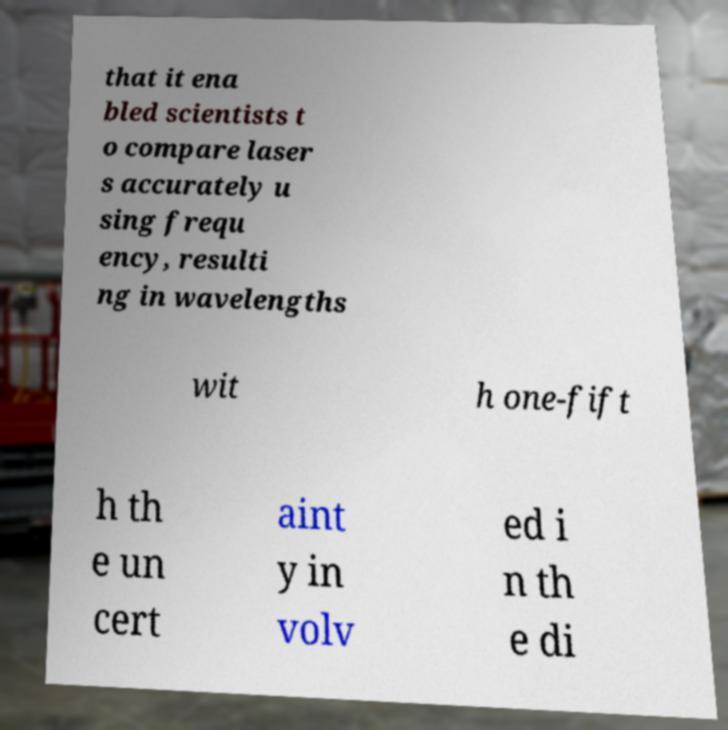There's text embedded in this image that I need extracted. Can you transcribe it verbatim? that it ena bled scientists t o compare laser s accurately u sing frequ ency, resulti ng in wavelengths wit h one-fift h th e un cert aint y in volv ed i n th e di 